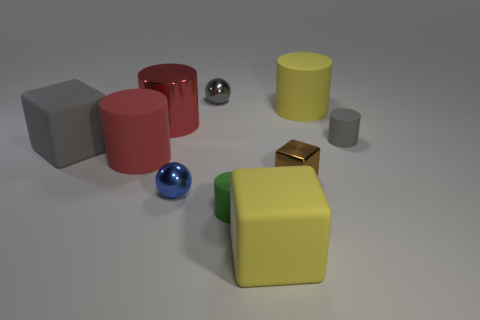Subtract all green cylinders. How many cylinders are left? 4 Subtract all large yellow cylinders. How many cylinders are left? 4 Subtract all brown cylinders. Subtract all yellow cubes. How many cylinders are left? 5 Subtract all cubes. How many objects are left? 7 Add 7 tiny green rubber cylinders. How many tiny green rubber cylinders exist? 8 Subtract 1 gray cylinders. How many objects are left? 9 Subtract all tiny gray objects. Subtract all small metallic things. How many objects are left? 5 Add 6 small blue metallic spheres. How many small blue metallic spheres are left? 7 